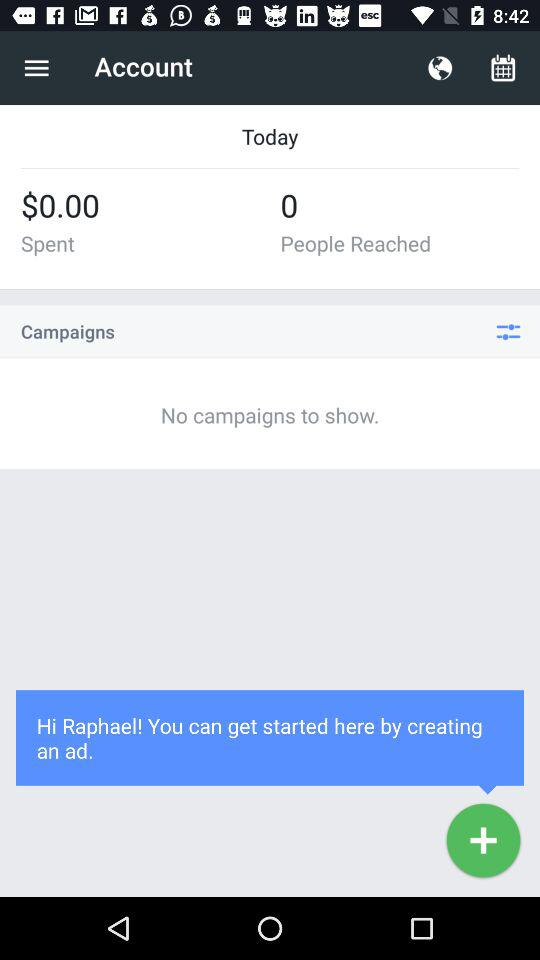How many people reached? There were 0 people reached. 